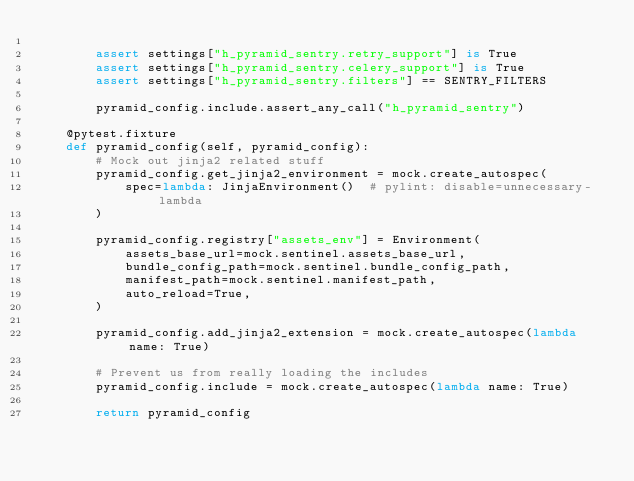<code> <loc_0><loc_0><loc_500><loc_500><_Python_>
        assert settings["h_pyramid_sentry.retry_support"] is True
        assert settings["h_pyramid_sentry.celery_support"] is True
        assert settings["h_pyramid_sentry.filters"] == SENTRY_FILTERS

        pyramid_config.include.assert_any_call("h_pyramid_sentry")

    @pytest.fixture
    def pyramid_config(self, pyramid_config):
        # Mock out jinja2 related stuff
        pyramid_config.get_jinja2_environment = mock.create_autospec(
            spec=lambda: JinjaEnvironment()  # pylint: disable=unnecessary-lambda
        )

        pyramid_config.registry["assets_env"] = Environment(
            assets_base_url=mock.sentinel.assets_base_url,
            bundle_config_path=mock.sentinel.bundle_config_path,
            manifest_path=mock.sentinel.manifest_path,
            auto_reload=True,
        )

        pyramid_config.add_jinja2_extension = mock.create_autospec(lambda name: True)

        # Prevent us from really loading the includes
        pyramid_config.include = mock.create_autospec(lambda name: True)

        return pyramid_config
</code> 